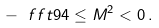Convert formula to latex. <formula><loc_0><loc_0><loc_500><loc_500>- \ f f t 9 4 \leq M ^ { 2 } < 0 \, .</formula> 